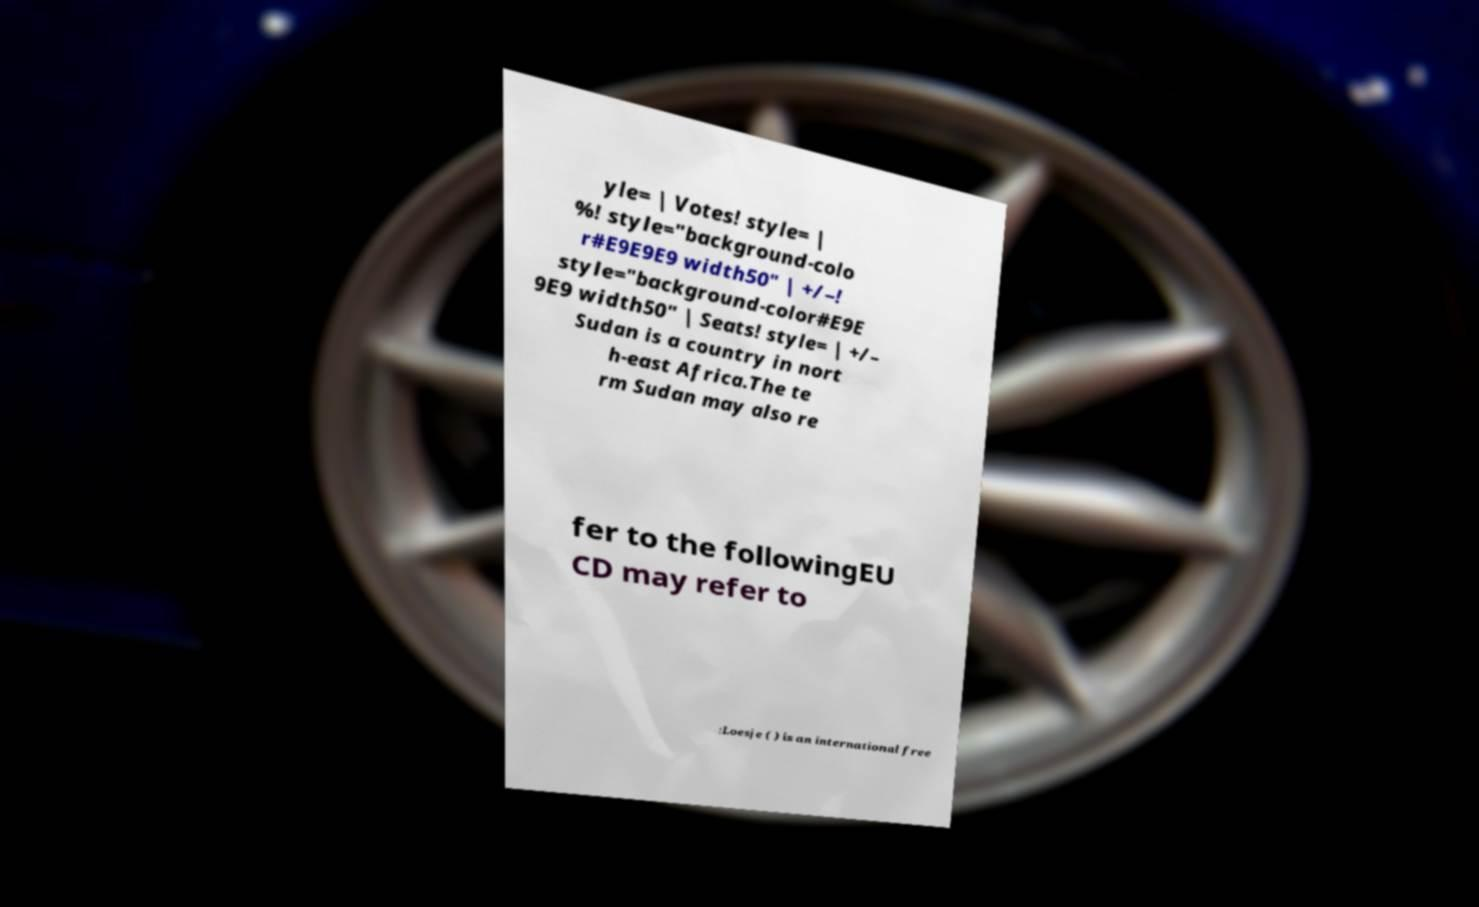Could you extract and type out the text from this image? yle= | Votes! style= | %! style="background-colo r#E9E9E9 width50" | +/–! style="background-color#E9E 9E9 width50" | Seats! style= | +/– Sudan is a country in nort h-east Africa.The te rm Sudan may also re fer to the followingEU CD may refer to :Loesje ( ) is an international free 